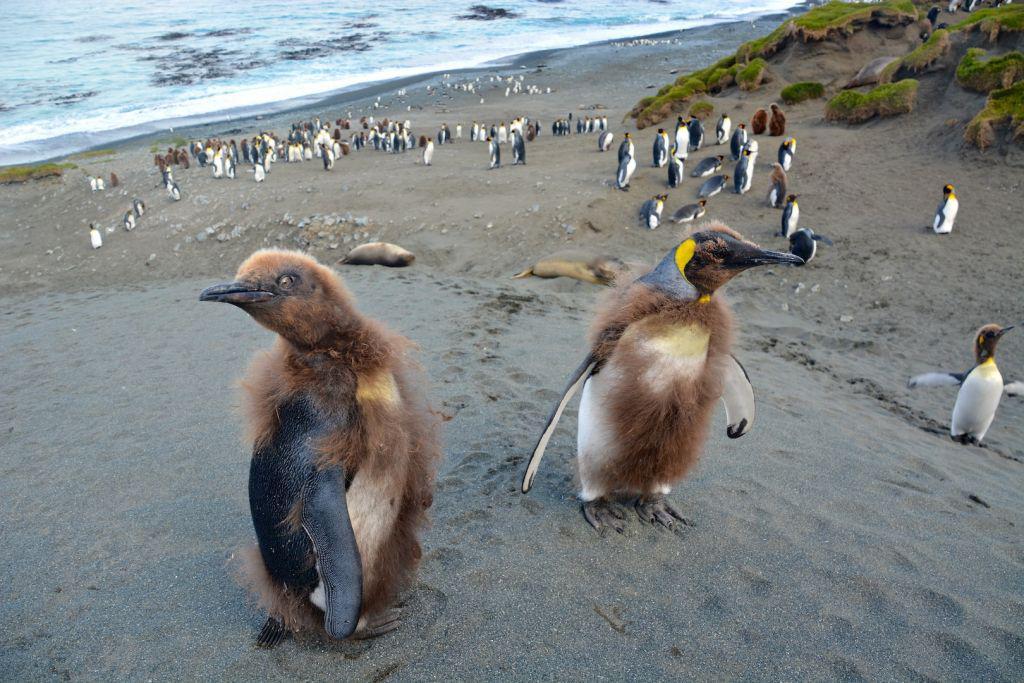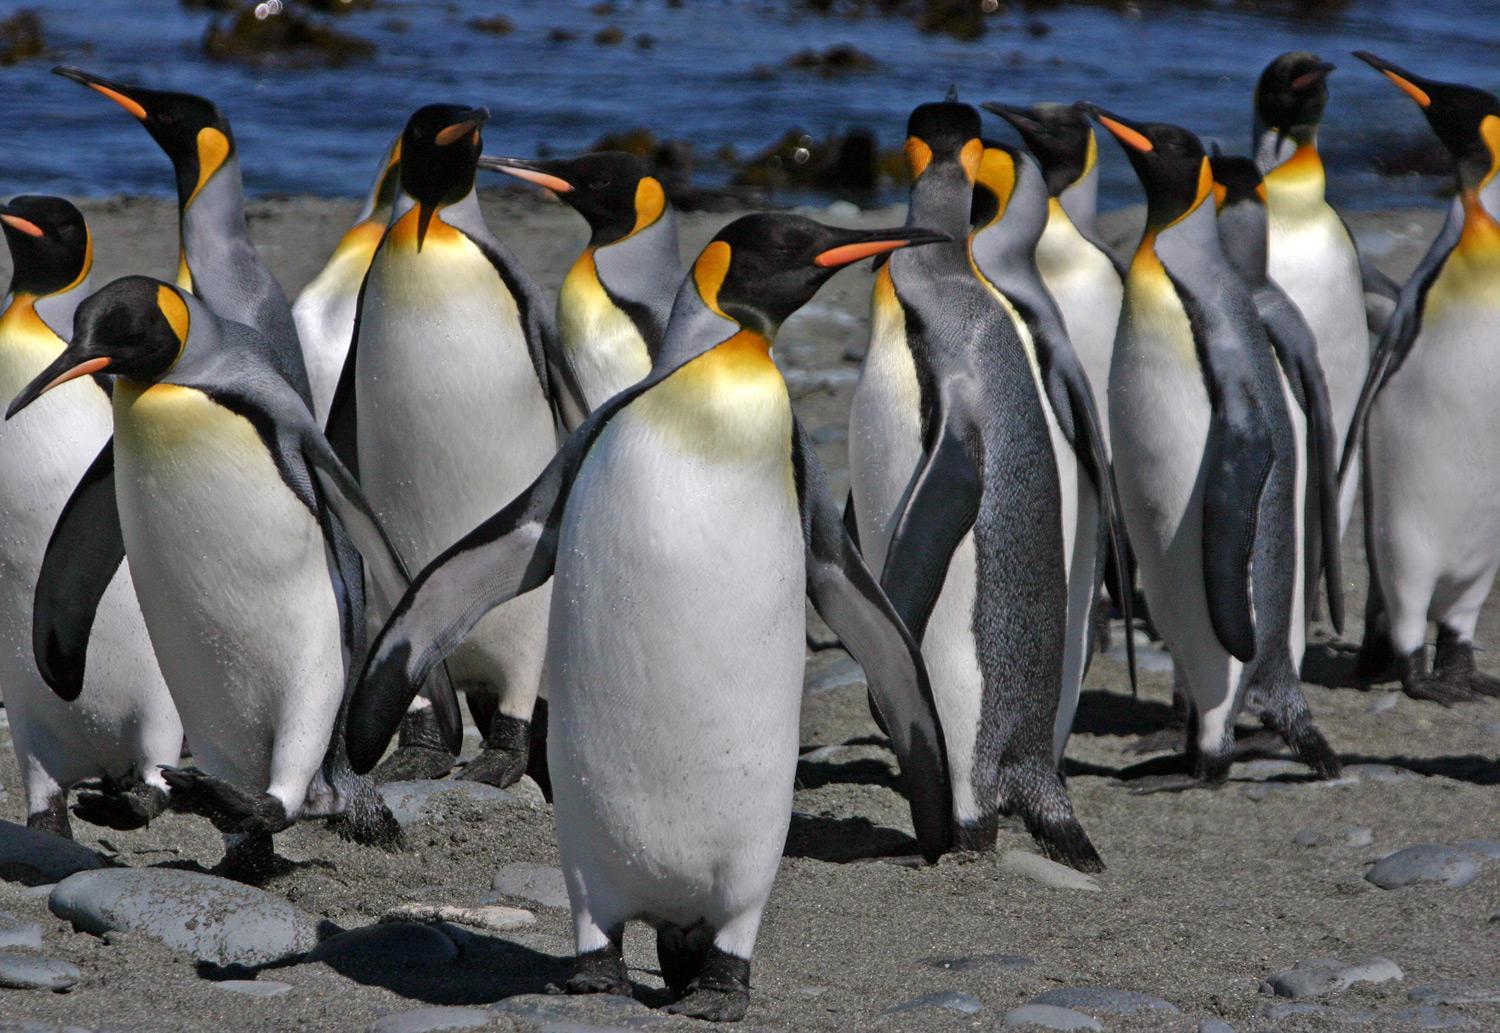The first image is the image on the left, the second image is the image on the right. Given the left and right images, does the statement "One of the pictures has only two penguins." hold true? Answer yes or no. No. The first image is the image on the left, the second image is the image on the right. For the images displayed, is the sentence "At least one image shows only two penguins." factually correct? Answer yes or no. No. 